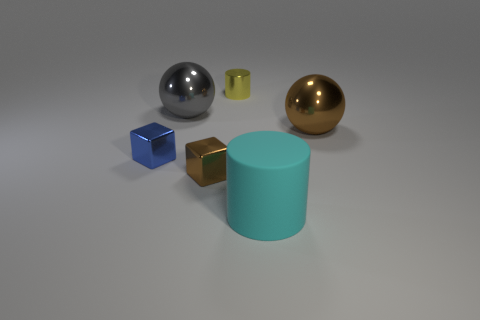Add 2 tiny cyan cylinders. How many objects exist? 8 Subtract all cylinders. How many objects are left? 4 Add 2 cyan matte objects. How many cyan matte objects are left? 3 Add 5 gray balls. How many gray balls exist? 6 Subtract 0 blue cylinders. How many objects are left? 6 Subtract all small blue matte things. Subtract all tiny blue shiny blocks. How many objects are left? 5 